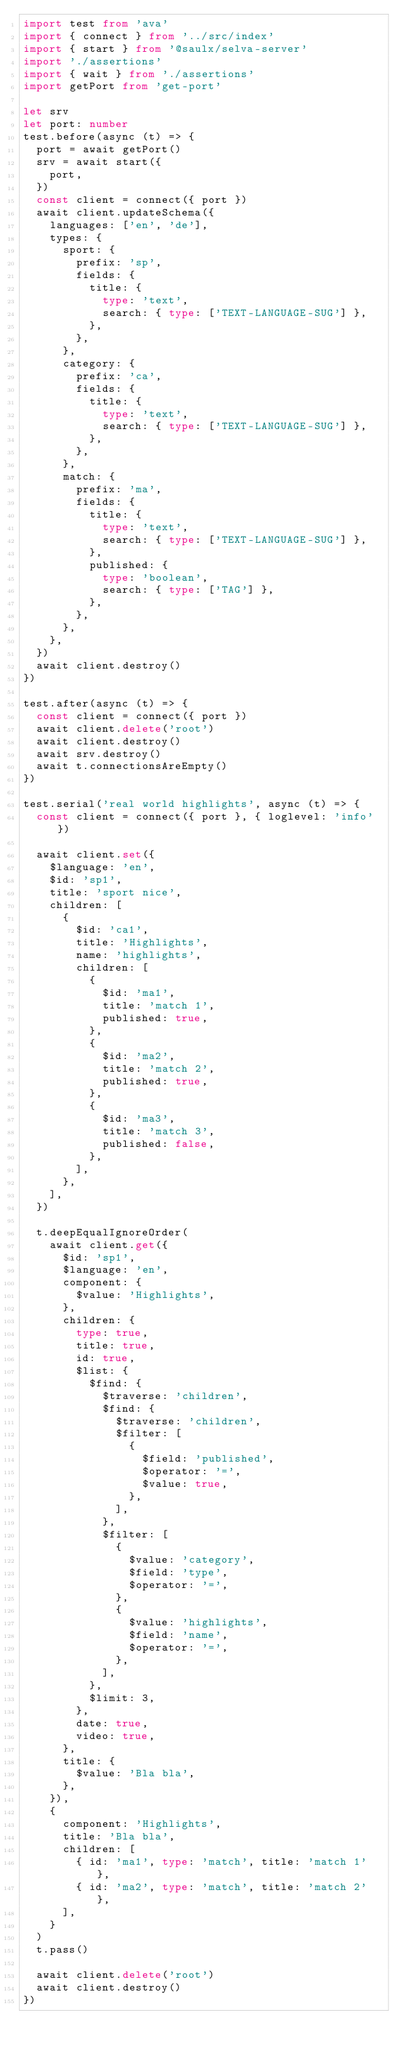<code> <loc_0><loc_0><loc_500><loc_500><_TypeScript_>import test from 'ava'
import { connect } from '../src/index'
import { start } from '@saulx/selva-server'
import './assertions'
import { wait } from './assertions'
import getPort from 'get-port'

let srv
let port: number
test.before(async (t) => {
  port = await getPort()
  srv = await start({
    port,
  })
  const client = connect({ port })
  await client.updateSchema({
    languages: ['en', 'de'],
    types: {
      sport: {
        prefix: 'sp',
        fields: {
          title: {
            type: 'text',
            search: { type: ['TEXT-LANGUAGE-SUG'] },
          },
        },
      },
      category: {
        prefix: 'ca',
        fields: {
          title: {
            type: 'text',
            search: { type: ['TEXT-LANGUAGE-SUG'] },
          },
        },
      },
      match: {
        prefix: 'ma',
        fields: {
          title: {
            type: 'text',
            search: { type: ['TEXT-LANGUAGE-SUG'] },
          },
          published: {
            type: 'boolean',
            search: { type: ['TAG'] },
          },
        },
      },
    },
  })
  await client.destroy()
})

test.after(async (t) => {
  const client = connect({ port })
  await client.delete('root')
  await client.destroy()
  await srv.destroy()
  await t.connectionsAreEmpty()
})

test.serial('real world highlights', async (t) => {
  const client = connect({ port }, { loglevel: 'info' })

  await client.set({
    $language: 'en',
    $id: 'sp1',
    title: 'sport nice',
    children: [
      {
        $id: 'ca1',
        title: 'Highlights',
        name: 'highlights',
        children: [
          {
            $id: 'ma1',
            title: 'match 1',
            published: true,
          },
          {
            $id: 'ma2',
            title: 'match 2',
            published: true,
          },
          {
            $id: 'ma3',
            title: 'match 3',
            published: false,
          },
        ],
      },
    ],
  })

  t.deepEqualIgnoreOrder(
    await client.get({
      $id: 'sp1',
      $language: 'en',
      component: {
        $value: 'Highlights',
      },
      children: {
        type: true,
        title: true,
        id: true,
        $list: {
          $find: {
            $traverse: 'children',
            $find: {
              $traverse: 'children',
              $filter: [
                {
                  $field: 'published',
                  $operator: '=',
                  $value: true,
                },
              ],
            },
            $filter: [
              {
                $value: 'category',
                $field: 'type',
                $operator: '=',
              },
              {
                $value: 'highlights',
                $field: 'name',
                $operator: '=',
              },
            ],
          },
          $limit: 3,
        },
        date: true,
        video: true,
      },
      title: {
        $value: 'Bla bla',
      },
    }),
    {
      component: 'Highlights',
      title: 'Bla bla',
      children: [
        { id: 'ma1', type: 'match', title: 'match 1' },
        { id: 'ma2', type: 'match', title: 'match 2' },
      ],
    }
  )
  t.pass()

  await client.delete('root')
  await client.destroy()
})
</code> 